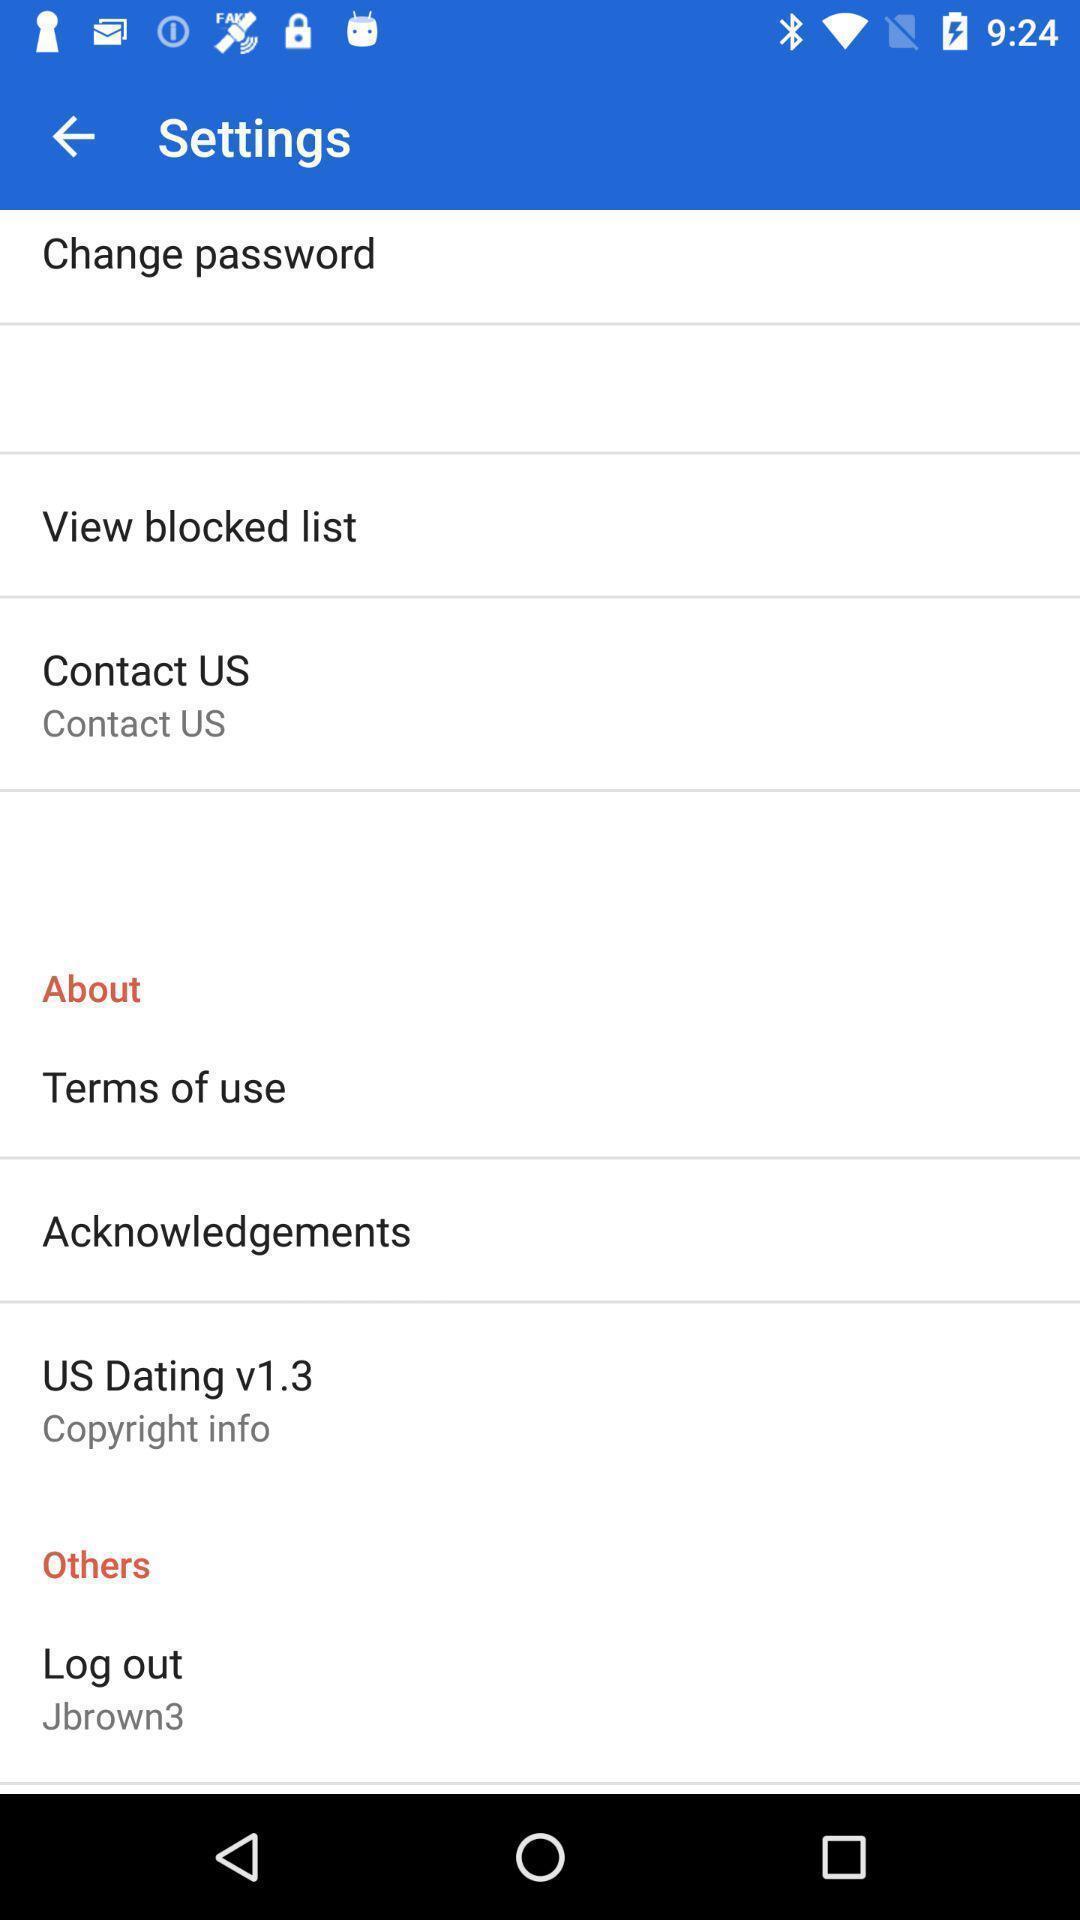Summarize the main components in this picture. Settings page with many other options. 